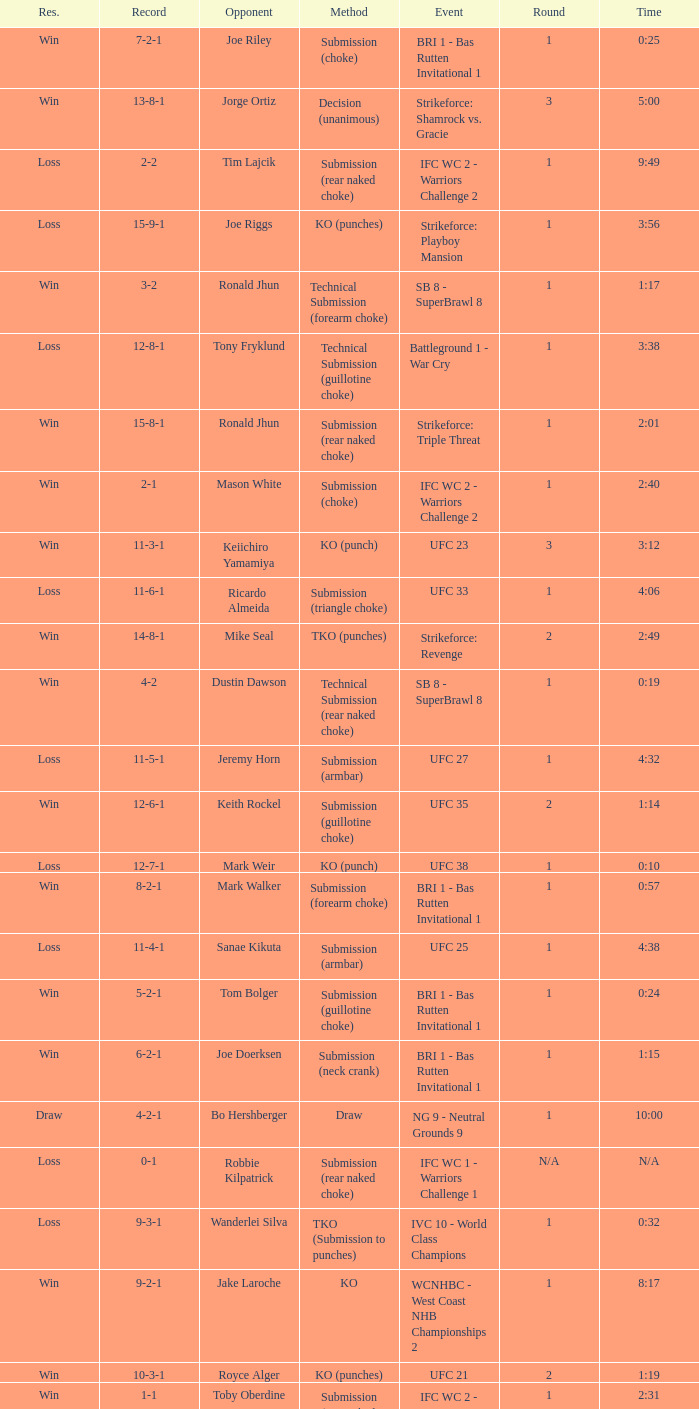What was the resolution for the fight against tom bolger by submission (guillotine choke)? Win. Could you parse the entire table? {'header': ['Res.', 'Record', 'Opponent', 'Method', 'Event', 'Round', 'Time'], 'rows': [['Win', '7-2-1', 'Joe Riley', 'Submission (choke)', 'BRI 1 - Bas Rutten Invitational 1', '1', '0:25'], ['Win', '13-8-1', 'Jorge Ortiz', 'Decision (unanimous)', 'Strikeforce: Shamrock vs. Gracie', '3', '5:00'], ['Loss', '2-2', 'Tim Lajcik', 'Submission (rear naked choke)', 'IFC WC 2 - Warriors Challenge 2', '1', '9:49'], ['Loss', '15-9-1', 'Joe Riggs', 'KO (punches)', 'Strikeforce: Playboy Mansion', '1', '3:56'], ['Win', '3-2', 'Ronald Jhun', 'Technical Submission (forearm choke)', 'SB 8 - SuperBrawl 8', '1', '1:17'], ['Loss', '12-8-1', 'Tony Fryklund', 'Technical Submission (guillotine choke)', 'Battleground 1 - War Cry', '1', '3:38'], ['Win', '15-8-1', 'Ronald Jhun', 'Submission (rear naked choke)', 'Strikeforce: Triple Threat', '1', '2:01'], ['Win', '2-1', 'Mason White', 'Submission (choke)', 'IFC WC 2 - Warriors Challenge 2', '1', '2:40'], ['Win', '11-3-1', 'Keiichiro Yamamiya', 'KO (punch)', 'UFC 23', '3', '3:12'], ['Loss', '11-6-1', 'Ricardo Almeida', 'Submission (triangle choke)', 'UFC 33', '1', '4:06'], ['Win', '14-8-1', 'Mike Seal', 'TKO (punches)', 'Strikeforce: Revenge', '2', '2:49'], ['Win', '4-2', 'Dustin Dawson', 'Technical Submission (rear naked choke)', 'SB 8 - SuperBrawl 8', '1', '0:19'], ['Loss', '11-5-1', 'Jeremy Horn', 'Submission (armbar)', 'UFC 27', '1', '4:32'], ['Win', '12-6-1', 'Keith Rockel', 'Submission (guillotine choke)', 'UFC 35', '2', '1:14'], ['Loss', '12-7-1', 'Mark Weir', 'KO (punch)', 'UFC 38', '1', '0:10'], ['Win', '8-2-1', 'Mark Walker', 'Submission (forearm choke)', 'BRI 1 - Bas Rutten Invitational 1', '1', '0:57'], ['Loss', '11-4-1', 'Sanae Kikuta', 'Submission (armbar)', 'UFC 25', '1', '4:38'], ['Win', '5-2-1', 'Tom Bolger', 'Submission (guillotine choke)', 'BRI 1 - Bas Rutten Invitational 1', '1', '0:24'], ['Win', '6-2-1', 'Joe Doerksen', 'Submission (neck crank)', 'BRI 1 - Bas Rutten Invitational 1', '1', '1:15'], ['Draw', '4-2-1', 'Bo Hershberger', 'Draw', 'NG 9 - Neutral Grounds 9', '1', '10:00'], ['Loss', '0-1', 'Robbie Kilpatrick', 'Submission (rear naked choke)', 'IFC WC 1 - Warriors Challenge 1', 'N/A', 'N/A'], ['Loss', '9-3-1', 'Wanderlei Silva', 'TKO (Submission to punches)', 'IVC 10 - World Class Champions', '1', '0:32'], ['Win', '9-2-1', 'Jake Laroche', 'KO', 'WCNHBC - West Coast NHB Championships 2', '1', '8:17'], ['Win', '10-3-1', 'Royce Alger', 'KO (punches)', 'UFC 21', '2', '1:19'], ['Win', '1-1', 'Toby Oberdine', 'Submission (rear naked choke)', 'IFC WC 2 - Warriors Challenge 2', '1', '2:31']]} 